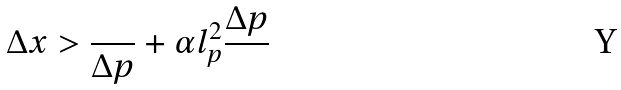Convert formula to latex. <formula><loc_0><loc_0><loc_500><loc_500>\Delta x > \frac { } { \Delta p } + \alpha l _ { p } ^ { 2 } \frac { \Delta p } { }</formula> 